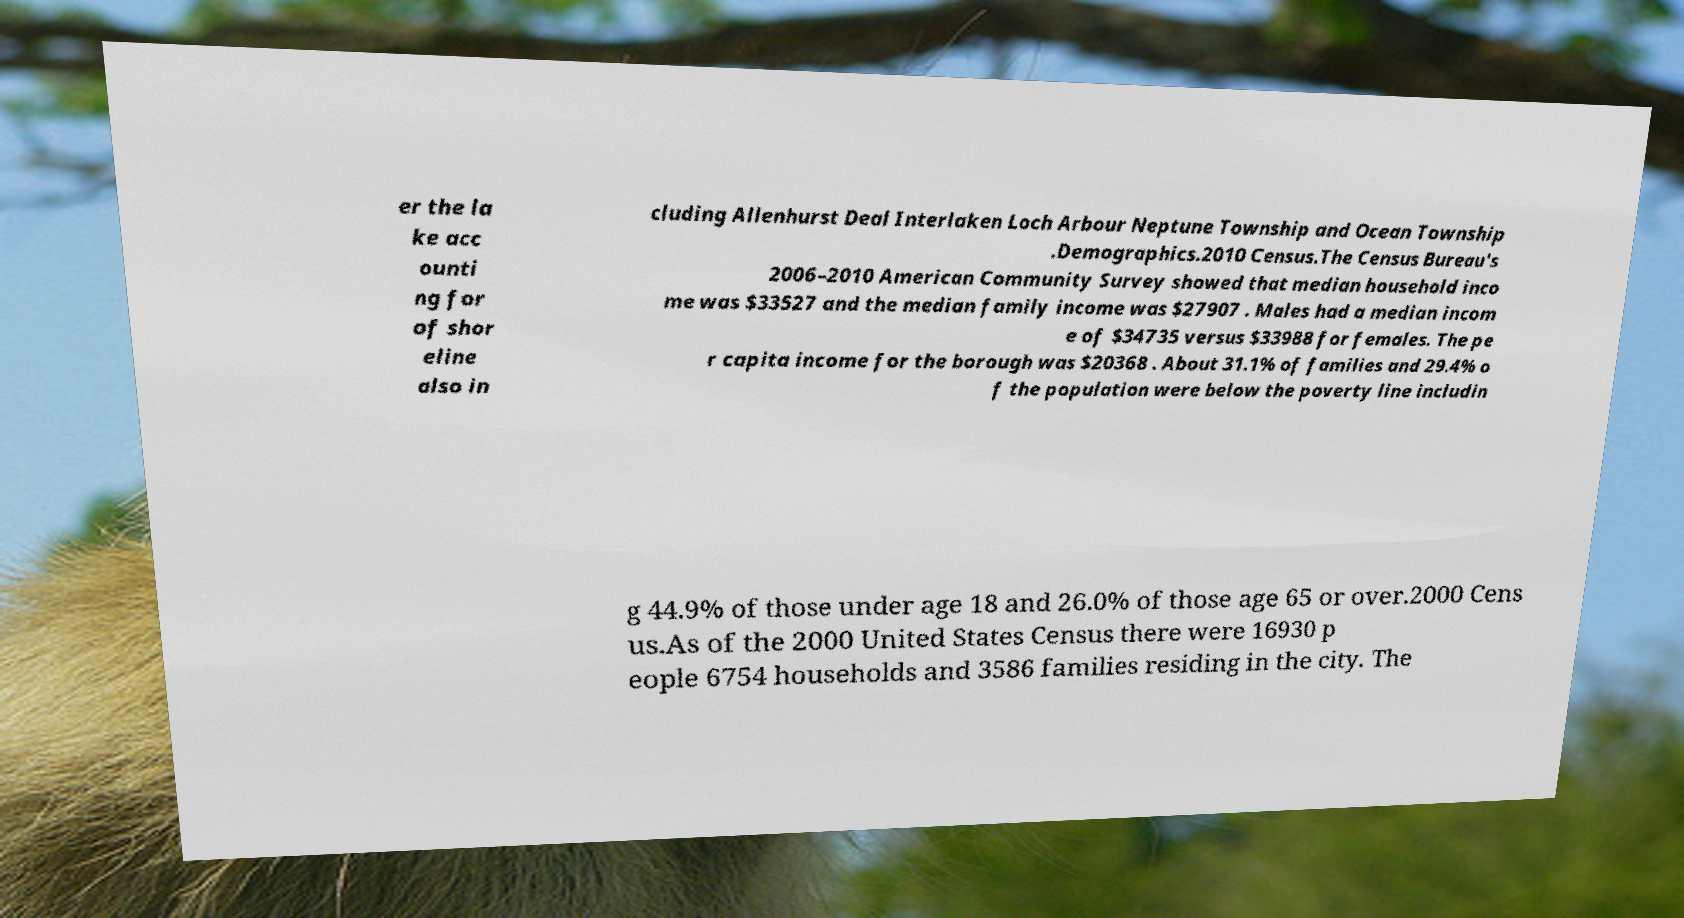Please read and relay the text visible in this image. What does it say? er the la ke acc ounti ng for of shor eline also in cluding Allenhurst Deal Interlaken Loch Arbour Neptune Township and Ocean Township .Demographics.2010 Census.The Census Bureau's 2006–2010 American Community Survey showed that median household inco me was $33527 and the median family income was $27907 . Males had a median incom e of $34735 versus $33988 for females. The pe r capita income for the borough was $20368 . About 31.1% of families and 29.4% o f the population were below the poverty line includin g 44.9% of those under age 18 and 26.0% of those age 65 or over.2000 Cens us.As of the 2000 United States Census there were 16930 p eople 6754 households and 3586 families residing in the city. The 